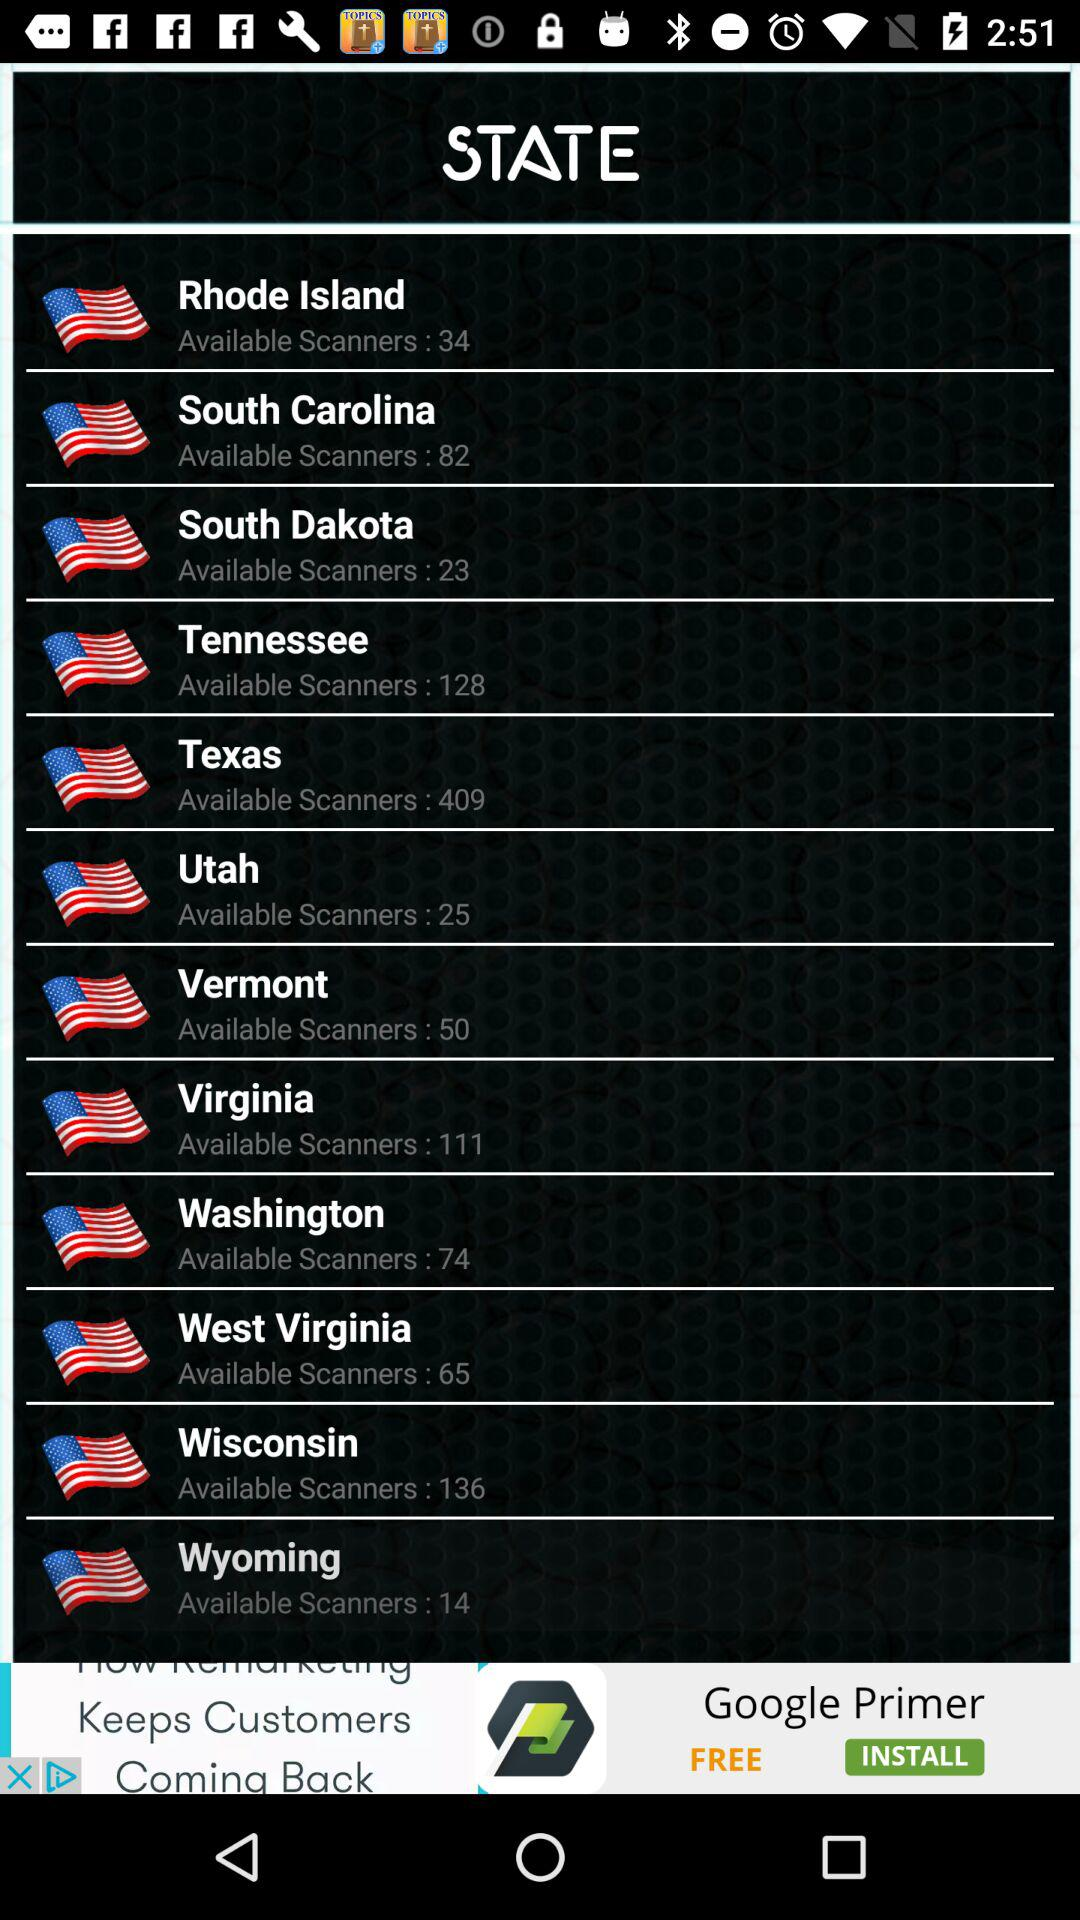Which state has the most available scanners?
Answer the question using a single word or phrase. Texas 